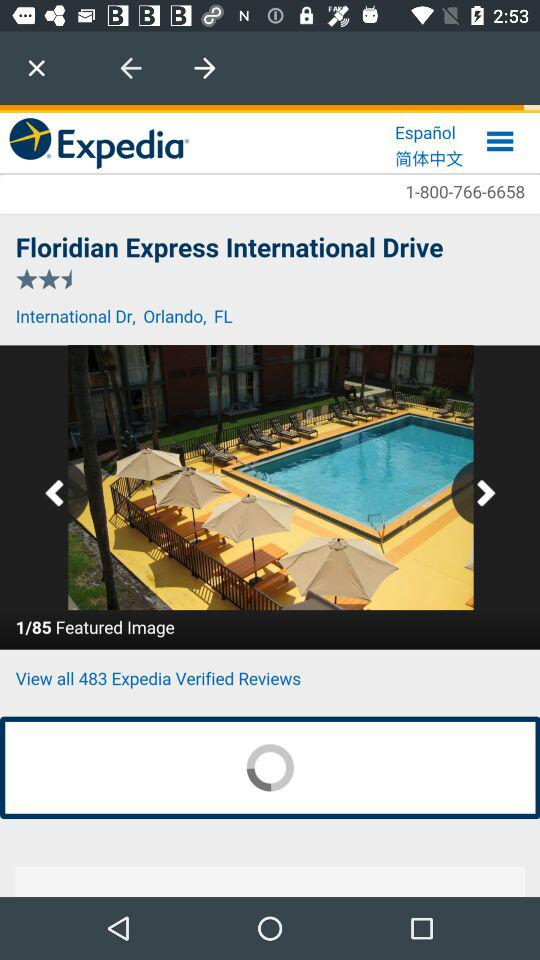What is the contact number of the hotel?
When the provided information is insufficient, respond with <no answer>. <no answer> 